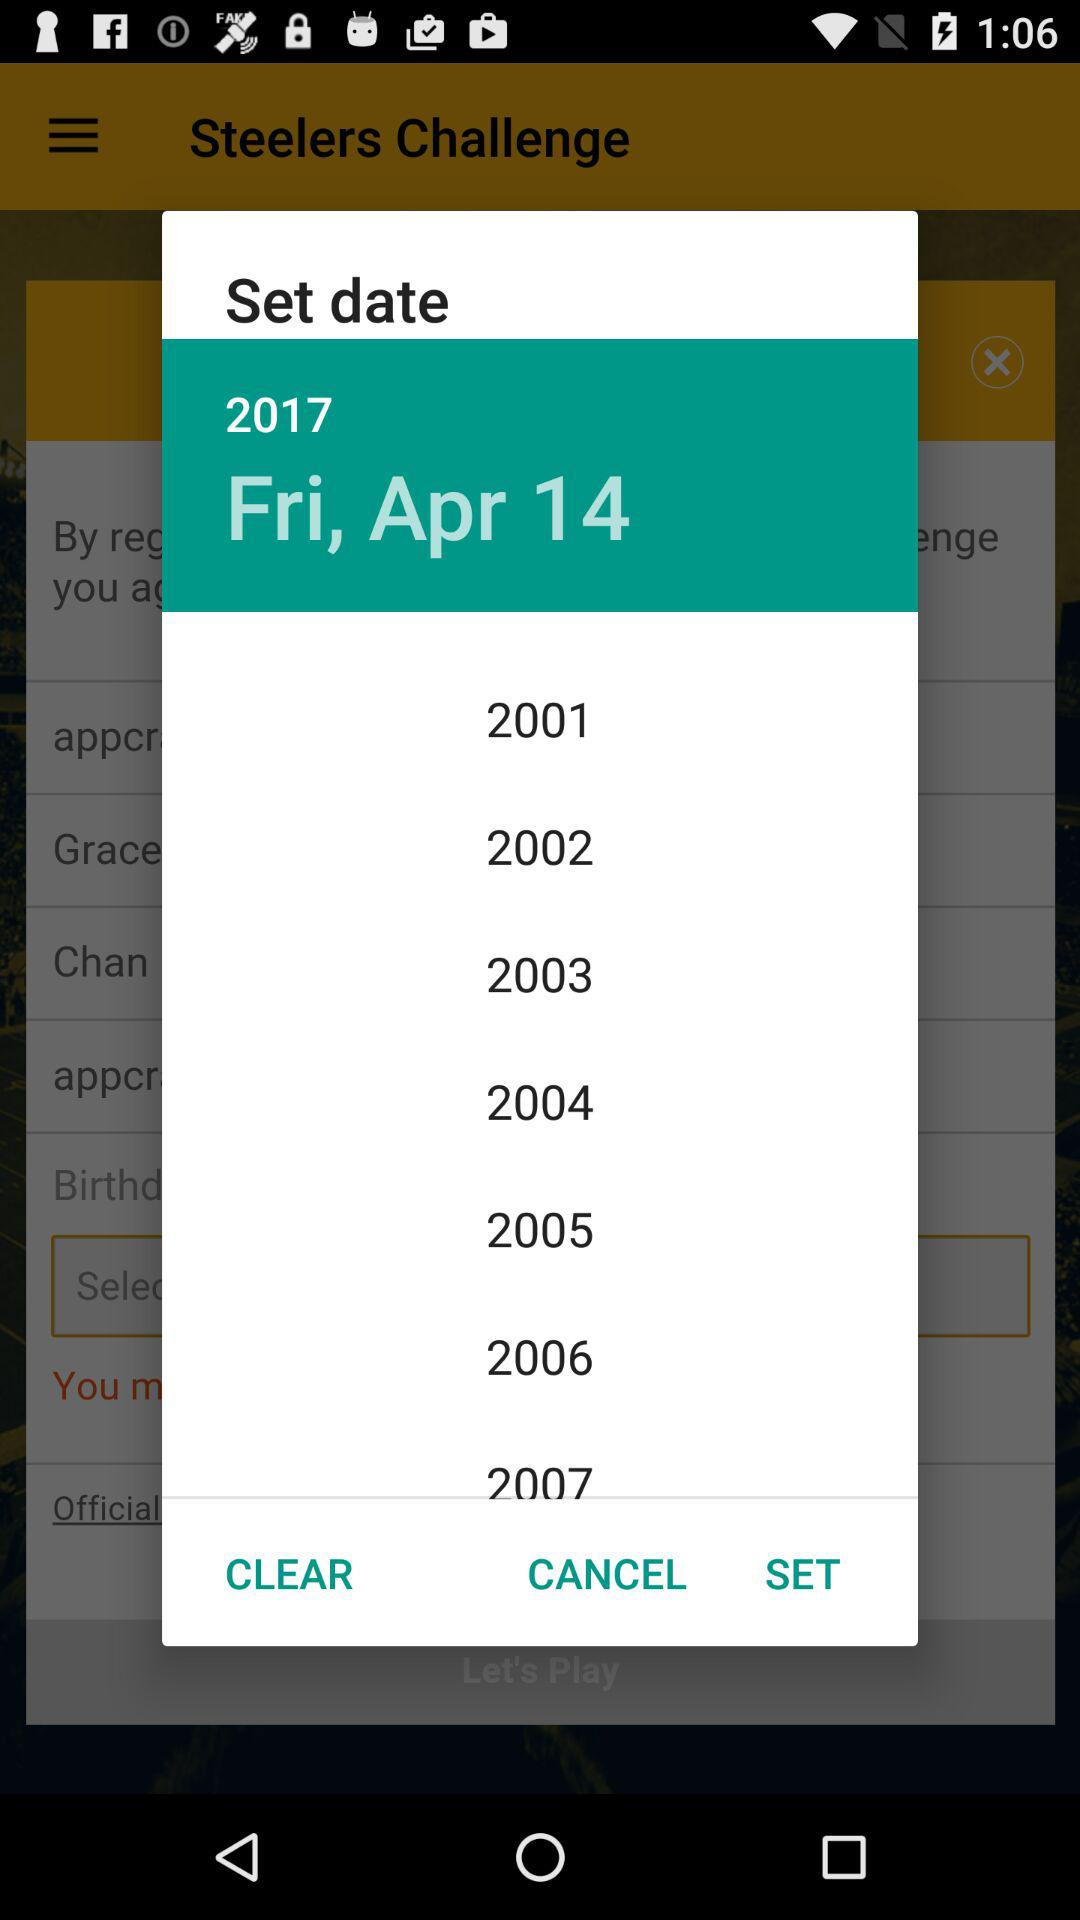What is the selected date? The selected date is Friday, April 14, 2017. 